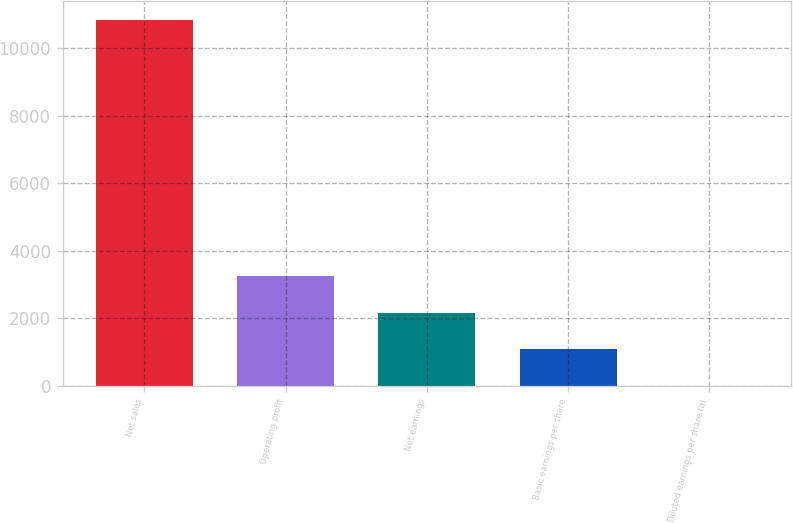Convert chart to OTSL. <chart><loc_0><loc_0><loc_500><loc_500><bar_chart><fcel>Net sales<fcel>Operating profit<fcel>Net earnings<fcel>Basic earnings per share<fcel>Diluted earnings per share (a)<nl><fcel>10840<fcel>3253.17<fcel>2169.34<fcel>1085.51<fcel>1.68<nl></chart> 